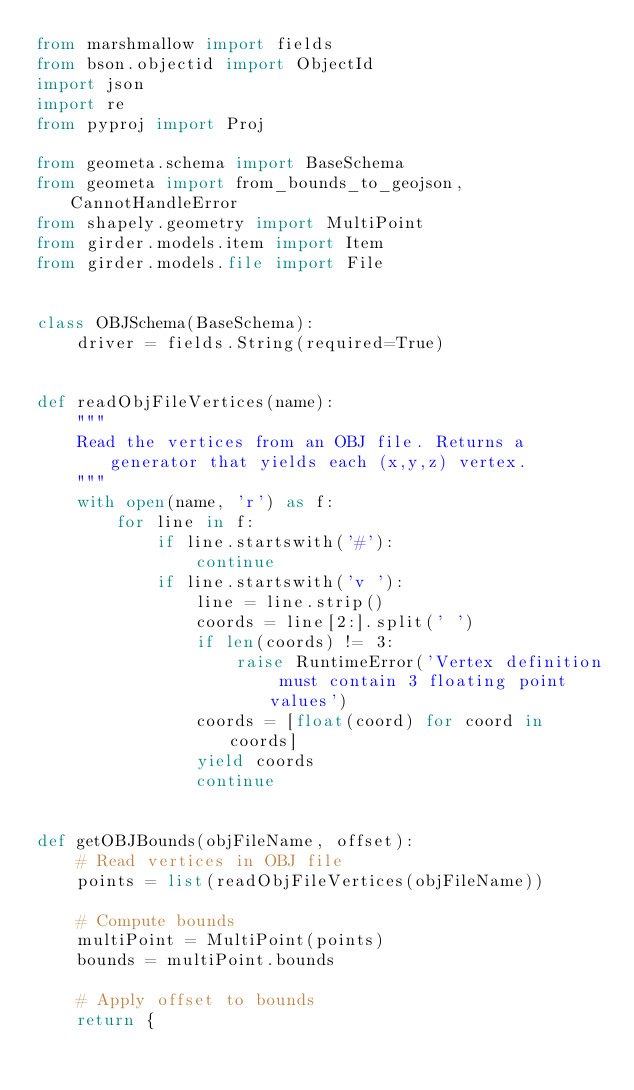<code> <loc_0><loc_0><loc_500><loc_500><_Python_>from marshmallow import fields
from bson.objectid import ObjectId
import json
import re
from pyproj import Proj

from geometa.schema import BaseSchema
from geometa import from_bounds_to_geojson, CannotHandleError
from shapely.geometry import MultiPoint
from girder.models.item import Item
from girder.models.file import File


class OBJSchema(BaseSchema):
    driver = fields.String(required=True)


def readObjFileVertices(name):
    """
    Read the vertices from an OBJ file. Returns a generator that yields each (x,y,z) vertex.
    """
    with open(name, 'r') as f:
        for line in f:
            if line.startswith('#'):
                continue
            if line.startswith('v '):
                line = line.strip()
                coords = line[2:].split(' ')
                if len(coords) != 3:
                    raise RuntimeError('Vertex definition must contain 3 floating point values')
                coords = [float(coord) for coord in coords]
                yield coords
                continue


def getOBJBounds(objFileName, offset):
    # Read vertices in OBJ file
    points = list(readObjFileVertices(objFileName))

    # Compute bounds
    multiPoint = MultiPoint(points)
    bounds = multiPoint.bounds

    # Apply offset to bounds
    return {</code> 